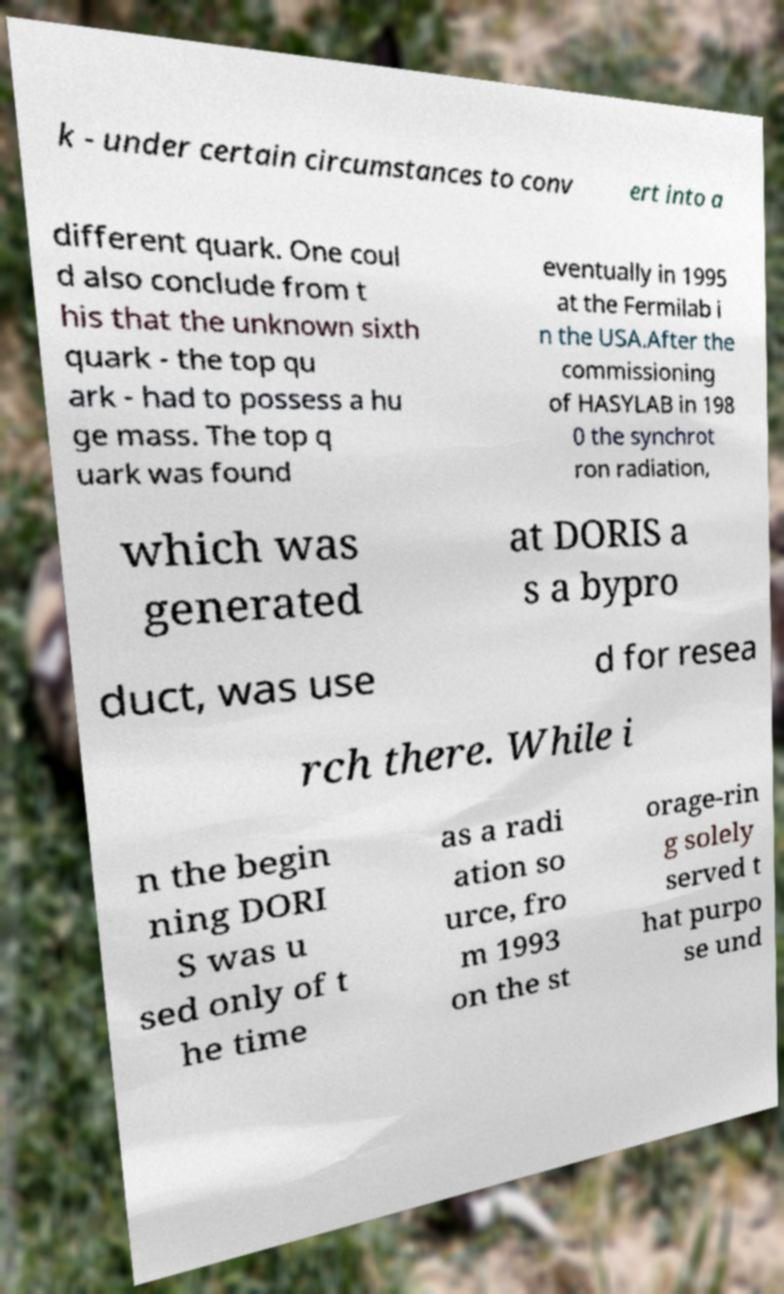Could you extract and type out the text from this image? k - under certain circumstances to conv ert into a different quark. One coul d also conclude from t his that the unknown sixth quark - the top qu ark - had to possess a hu ge mass. The top q uark was found eventually in 1995 at the Fermilab i n the USA.After the commissioning of HASYLAB in 198 0 the synchrot ron radiation, which was generated at DORIS a s a bypro duct, was use d for resea rch there. While i n the begin ning DORI S was u sed only of t he time as a radi ation so urce, fro m 1993 on the st orage-rin g solely served t hat purpo se und 